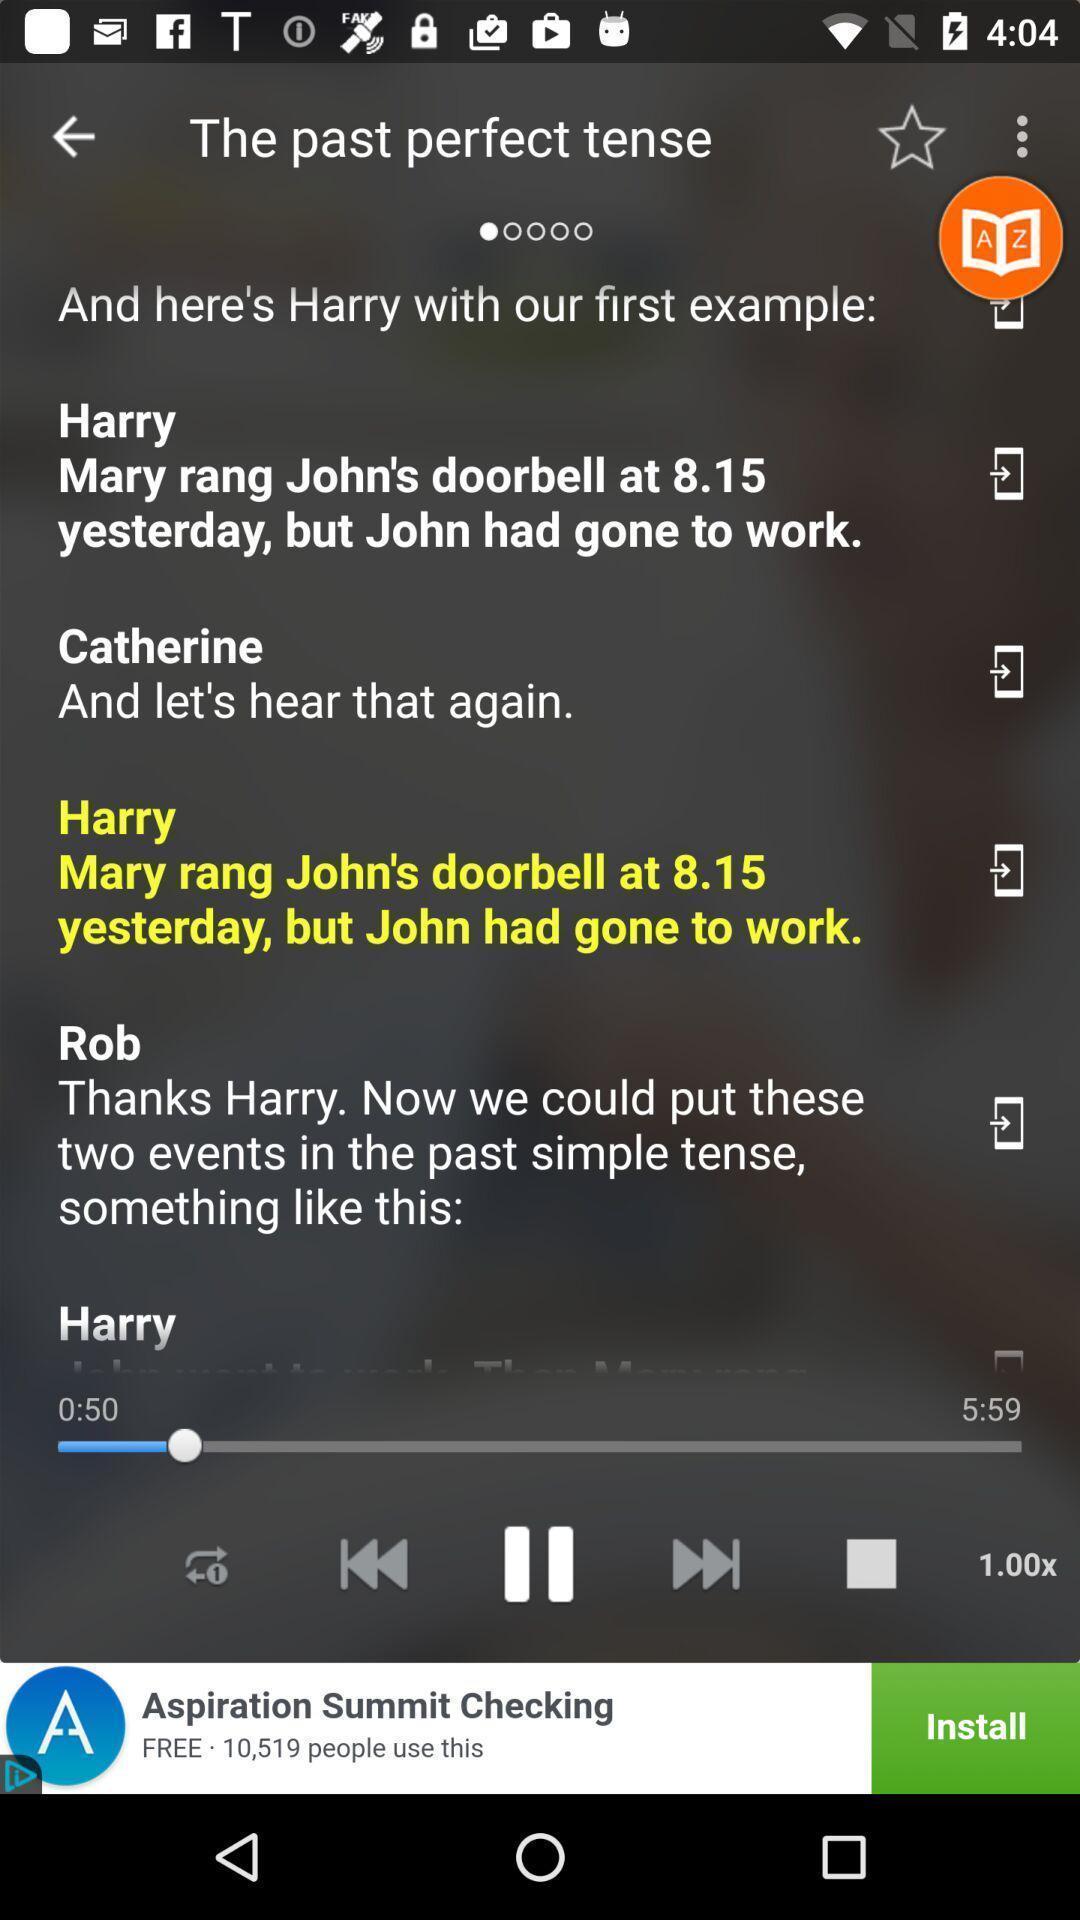Explain the elements present in this screenshot. Various examples displayed in language leaning app. 